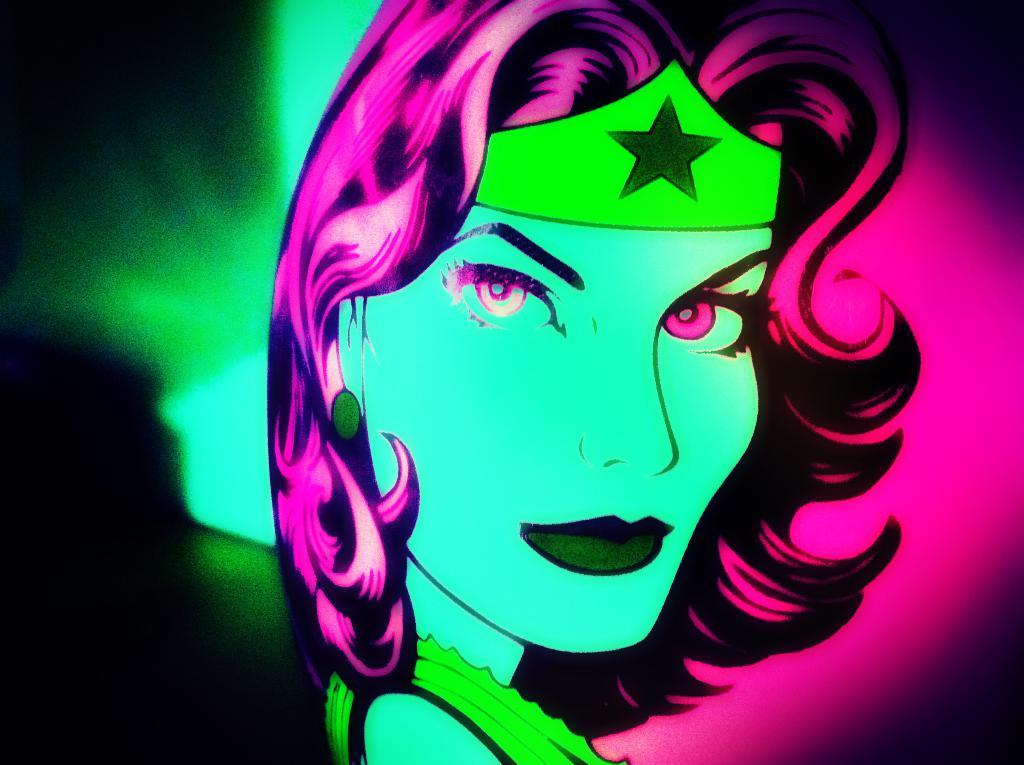What type of art is depicted in the image? The image is a digital art. Who or what is the main subject of the digital art? The subject of the digital art is a woman. Where is the library located in the image? There is no library present in the image; it features a digital art of a woman. 